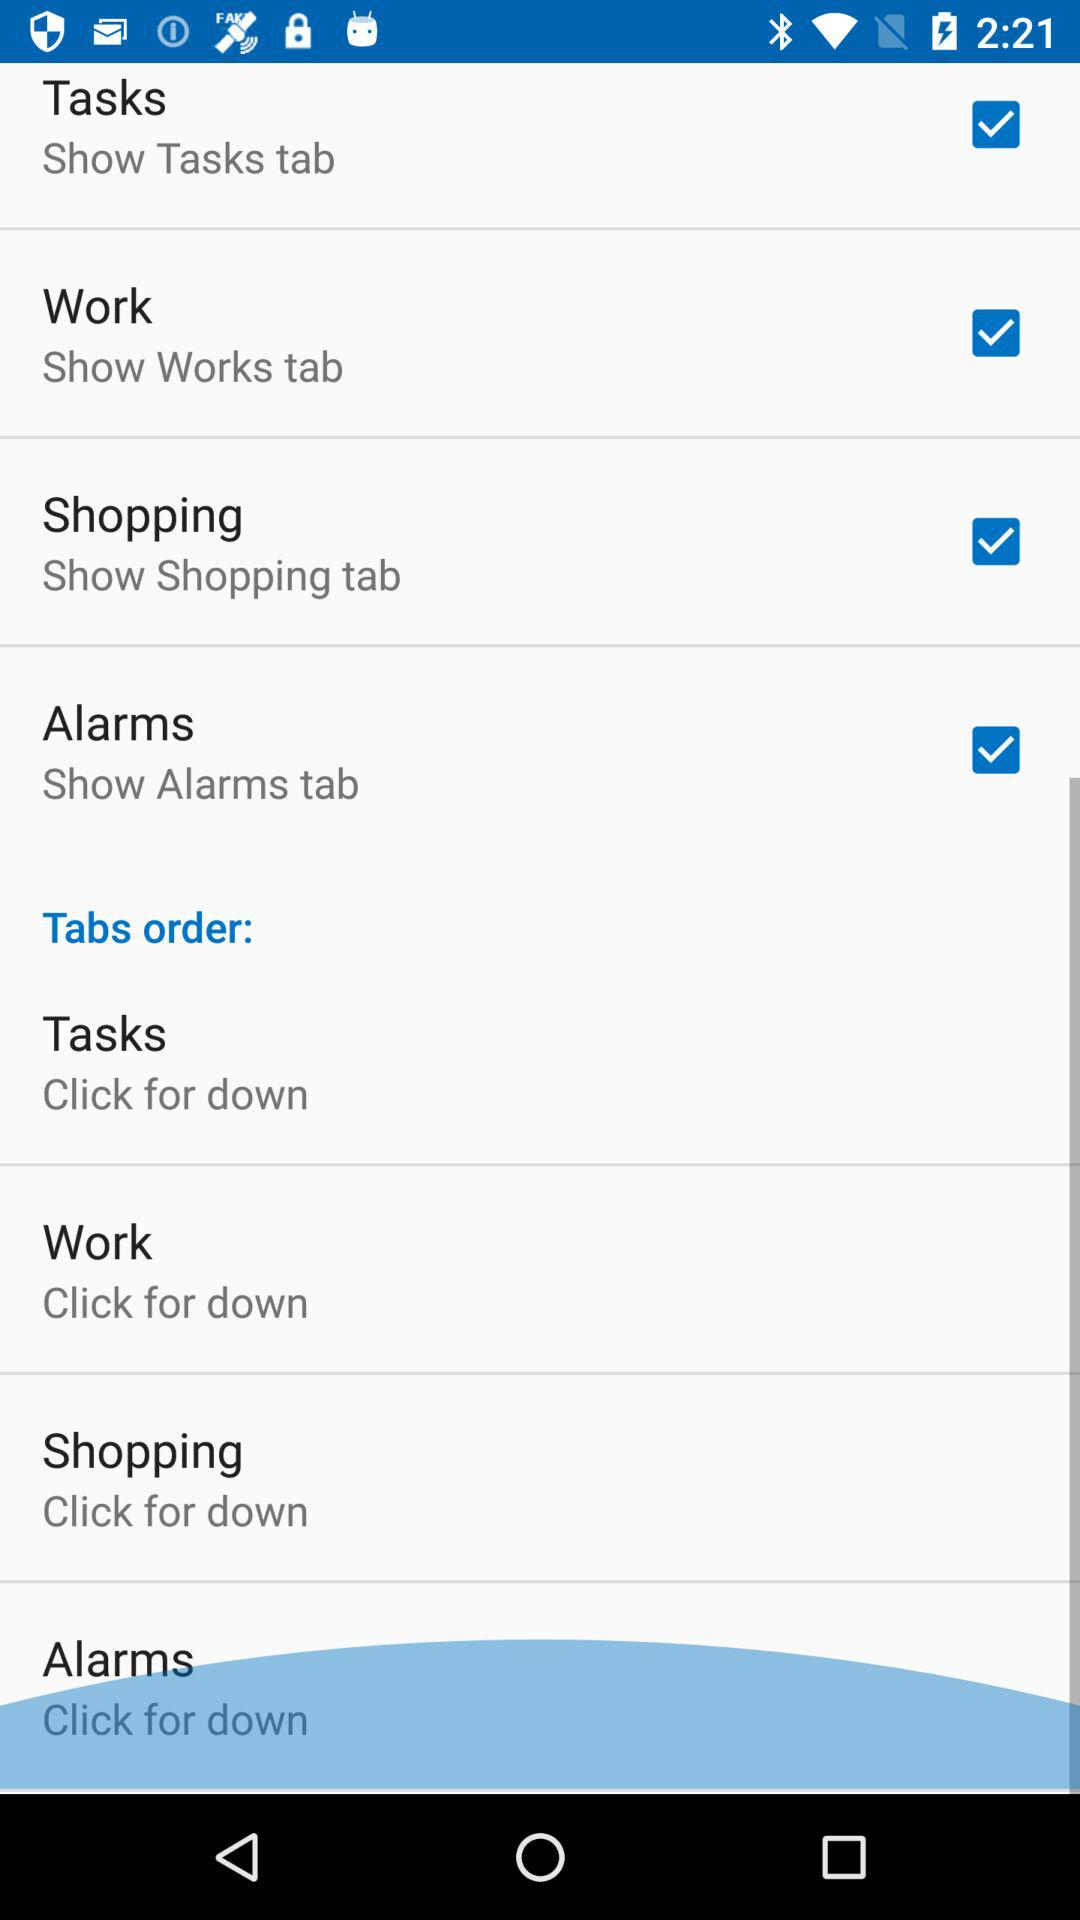What is the status of the "Alarms"? The status is "on". 